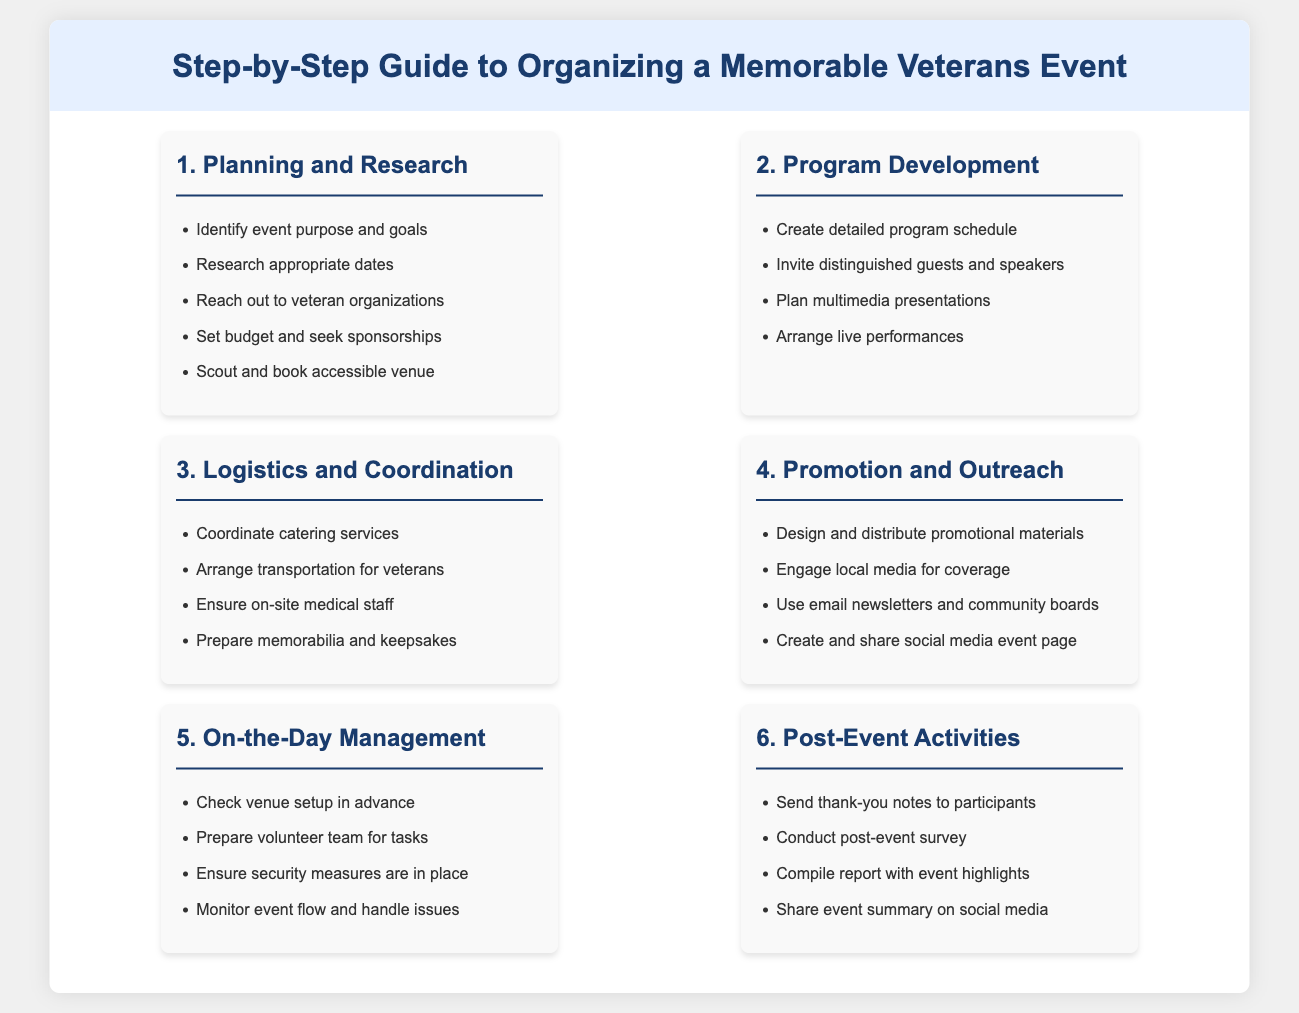What is the first step in organizing a veterans event? The first step listed in the document is "Planning and Research."
Answer: Planning and Research How many steps are outlined in the guide? The guide outlines a total of six steps.
Answer: Six What is one task under Program Development? One task listed under Program Development is "Invite distinguished guests and speakers."
Answer: Invite distinguished guests and speakers What should be prepared on the day of the event? The document states that the "volunteer team for tasks" should be prepared on the day of the event.
Answer: Volunteer team for tasks What is the last activity mentioned in Post-Event Activities? The last activity mentioned is "Share event summary on social media."
Answer: Share event summary on social media Which step involves coordinating catering services? The step that involves coordinating catering services is "Logistics and Coordination."
Answer: Logistics and Coordination 